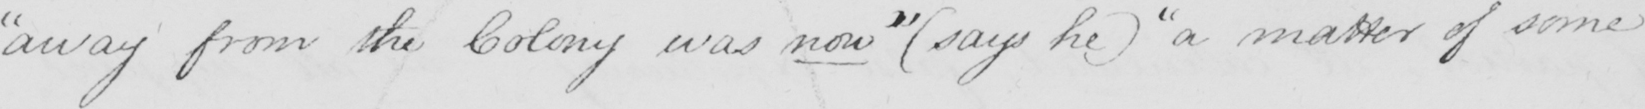Can you tell me what this handwritten text says? " away from the Colony was now "   ( says he )   " a matter of some 